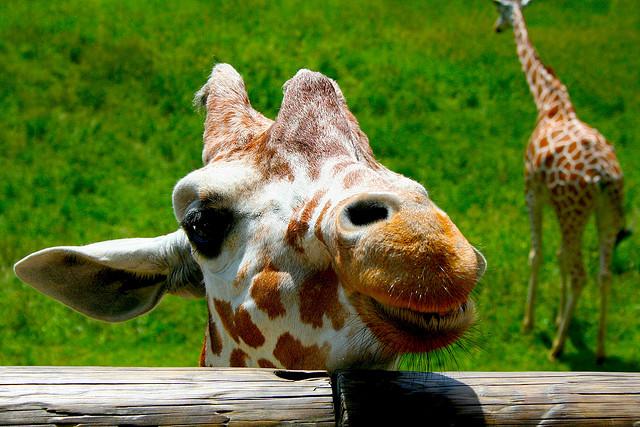How many ears does the main giraffe likely have?
Concise answer only. 2. Which animals are these?
Write a very short answer. Giraffes. Is the giraffe showing its tongue?
Be succinct. No. 